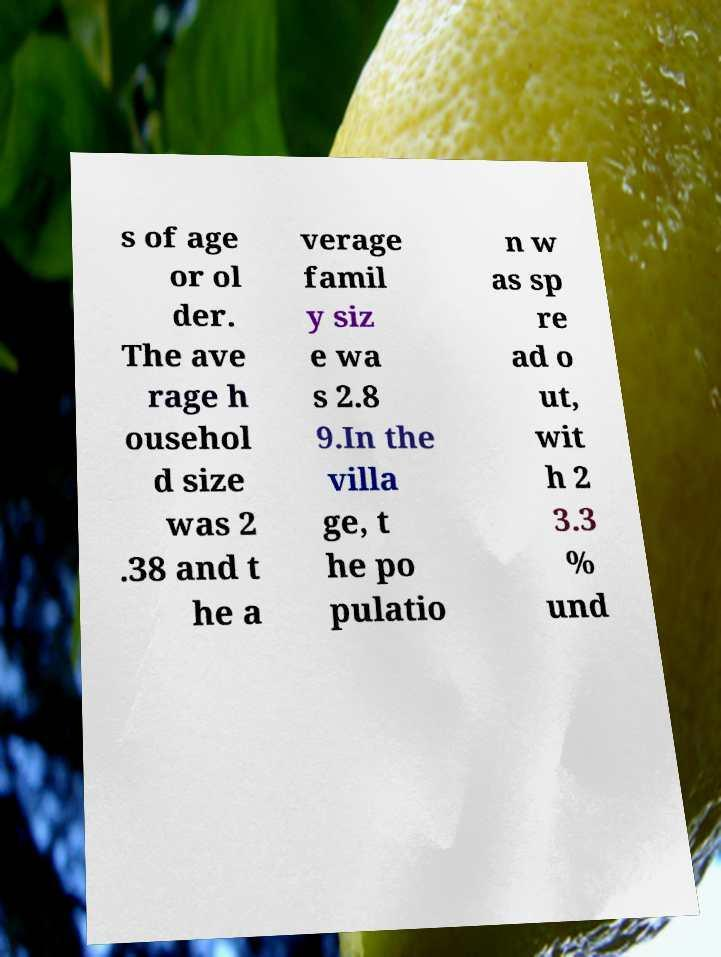For documentation purposes, I need the text within this image transcribed. Could you provide that? s of age or ol der. The ave rage h ousehol d size was 2 .38 and t he a verage famil y siz e wa s 2.8 9.In the villa ge, t he po pulatio n w as sp re ad o ut, wit h 2 3.3 % und 